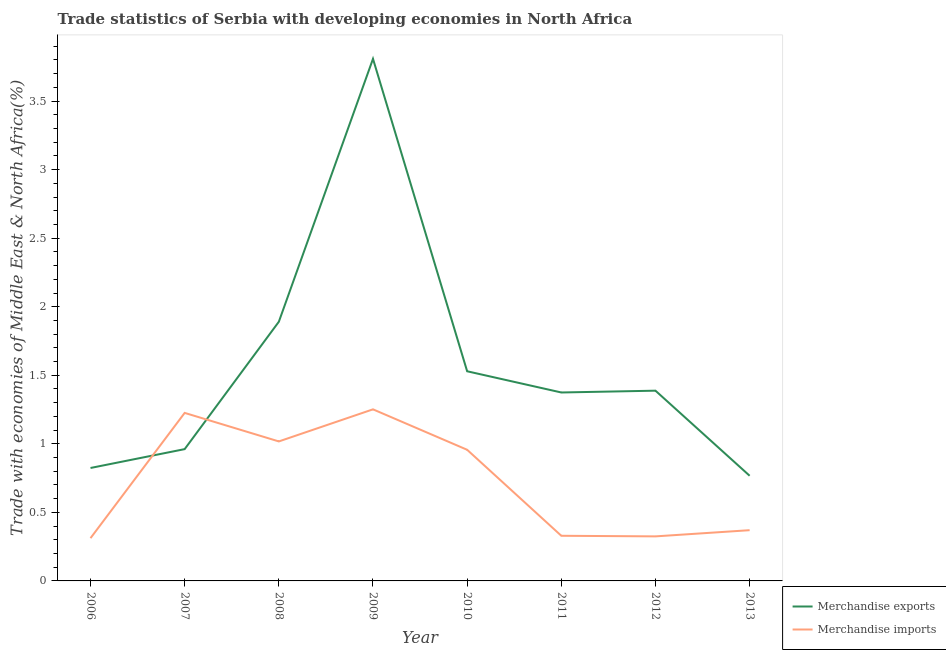How many different coloured lines are there?
Offer a very short reply. 2. Is the number of lines equal to the number of legend labels?
Your answer should be very brief. Yes. What is the merchandise exports in 2013?
Keep it short and to the point. 0.77. Across all years, what is the maximum merchandise exports?
Your answer should be very brief. 3.81. Across all years, what is the minimum merchandise imports?
Provide a succinct answer. 0.31. In which year was the merchandise exports maximum?
Your answer should be compact. 2009. In which year was the merchandise exports minimum?
Provide a short and direct response. 2013. What is the total merchandise exports in the graph?
Ensure brevity in your answer.  12.54. What is the difference between the merchandise exports in 2007 and that in 2011?
Make the answer very short. -0.41. What is the difference between the merchandise exports in 2012 and the merchandise imports in 2013?
Ensure brevity in your answer.  1.02. What is the average merchandise exports per year?
Provide a short and direct response. 1.57. In the year 2011, what is the difference between the merchandise imports and merchandise exports?
Ensure brevity in your answer.  -1.05. In how many years, is the merchandise exports greater than 1.1 %?
Offer a very short reply. 5. What is the ratio of the merchandise exports in 2007 to that in 2009?
Provide a succinct answer. 0.25. What is the difference between the highest and the second highest merchandise exports?
Offer a terse response. 1.92. What is the difference between the highest and the lowest merchandise exports?
Your response must be concise. 3.04. Is the sum of the merchandise exports in 2009 and 2010 greater than the maximum merchandise imports across all years?
Keep it short and to the point. Yes. Does the merchandise exports monotonically increase over the years?
Offer a terse response. No. How many years are there in the graph?
Provide a short and direct response. 8. What is the difference between two consecutive major ticks on the Y-axis?
Provide a succinct answer. 0.5. Does the graph contain grids?
Keep it short and to the point. No. Where does the legend appear in the graph?
Ensure brevity in your answer.  Bottom right. How are the legend labels stacked?
Your response must be concise. Vertical. What is the title of the graph?
Provide a short and direct response. Trade statistics of Serbia with developing economies in North Africa. What is the label or title of the X-axis?
Provide a short and direct response. Year. What is the label or title of the Y-axis?
Your answer should be compact. Trade with economies of Middle East & North Africa(%). What is the Trade with economies of Middle East & North Africa(%) in Merchandise exports in 2006?
Offer a very short reply. 0.82. What is the Trade with economies of Middle East & North Africa(%) of Merchandise imports in 2006?
Provide a succinct answer. 0.31. What is the Trade with economies of Middle East & North Africa(%) in Merchandise exports in 2007?
Offer a very short reply. 0.96. What is the Trade with economies of Middle East & North Africa(%) of Merchandise imports in 2007?
Your answer should be very brief. 1.23. What is the Trade with economies of Middle East & North Africa(%) in Merchandise exports in 2008?
Your answer should be very brief. 1.89. What is the Trade with economies of Middle East & North Africa(%) in Merchandise imports in 2008?
Keep it short and to the point. 1.02. What is the Trade with economies of Middle East & North Africa(%) of Merchandise exports in 2009?
Offer a terse response. 3.81. What is the Trade with economies of Middle East & North Africa(%) of Merchandise imports in 2009?
Give a very brief answer. 1.25. What is the Trade with economies of Middle East & North Africa(%) in Merchandise exports in 2010?
Your response must be concise. 1.53. What is the Trade with economies of Middle East & North Africa(%) of Merchandise imports in 2010?
Keep it short and to the point. 0.96. What is the Trade with economies of Middle East & North Africa(%) of Merchandise exports in 2011?
Your answer should be very brief. 1.37. What is the Trade with economies of Middle East & North Africa(%) of Merchandise imports in 2011?
Give a very brief answer. 0.33. What is the Trade with economies of Middle East & North Africa(%) in Merchandise exports in 2012?
Your response must be concise. 1.39. What is the Trade with economies of Middle East & North Africa(%) in Merchandise imports in 2012?
Provide a short and direct response. 0.32. What is the Trade with economies of Middle East & North Africa(%) in Merchandise exports in 2013?
Offer a very short reply. 0.77. What is the Trade with economies of Middle East & North Africa(%) of Merchandise imports in 2013?
Your response must be concise. 0.37. Across all years, what is the maximum Trade with economies of Middle East & North Africa(%) of Merchandise exports?
Your answer should be compact. 3.81. Across all years, what is the maximum Trade with economies of Middle East & North Africa(%) of Merchandise imports?
Provide a short and direct response. 1.25. Across all years, what is the minimum Trade with economies of Middle East & North Africa(%) in Merchandise exports?
Your answer should be compact. 0.77. Across all years, what is the minimum Trade with economies of Middle East & North Africa(%) in Merchandise imports?
Give a very brief answer. 0.31. What is the total Trade with economies of Middle East & North Africa(%) in Merchandise exports in the graph?
Your answer should be very brief. 12.54. What is the total Trade with economies of Middle East & North Africa(%) in Merchandise imports in the graph?
Provide a succinct answer. 5.79. What is the difference between the Trade with economies of Middle East & North Africa(%) in Merchandise exports in 2006 and that in 2007?
Offer a terse response. -0.14. What is the difference between the Trade with economies of Middle East & North Africa(%) in Merchandise imports in 2006 and that in 2007?
Keep it short and to the point. -0.91. What is the difference between the Trade with economies of Middle East & North Africa(%) of Merchandise exports in 2006 and that in 2008?
Give a very brief answer. -1.07. What is the difference between the Trade with economies of Middle East & North Africa(%) of Merchandise imports in 2006 and that in 2008?
Your answer should be compact. -0.71. What is the difference between the Trade with economies of Middle East & North Africa(%) in Merchandise exports in 2006 and that in 2009?
Your response must be concise. -2.98. What is the difference between the Trade with economies of Middle East & North Africa(%) of Merchandise imports in 2006 and that in 2009?
Offer a terse response. -0.94. What is the difference between the Trade with economies of Middle East & North Africa(%) in Merchandise exports in 2006 and that in 2010?
Make the answer very short. -0.71. What is the difference between the Trade with economies of Middle East & North Africa(%) in Merchandise imports in 2006 and that in 2010?
Offer a terse response. -0.64. What is the difference between the Trade with economies of Middle East & North Africa(%) in Merchandise exports in 2006 and that in 2011?
Your answer should be compact. -0.55. What is the difference between the Trade with economies of Middle East & North Africa(%) of Merchandise imports in 2006 and that in 2011?
Make the answer very short. -0.02. What is the difference between the Trade with economies of Middle East & North Africa(%) of Merchandise exports in 2006 and that in 2012?
Keep it short and to the point. -0.56. What is the difference between the Trade with economies of Middle East & North Africa(%) of Merchandise imports in 2006 and that in 2012?
Ensure brevity in your answer.  -0.01. What is the difference between the Trade with economies of Middle East & North Africa(%) in Merchandise exports in 2006 and that in 2013?
Give a very brief answer. 0.06. What is the difference between the Trade with economies of Middle East & North Africa(%) of Merchandise imports in 2006 and that in 2013?
Your answer should be compact. -0.06. What is the difference between the Trade with economies of Middle East & North Africa(%) in Merchandise exports in 2007 and that in 2008?
Offer a very short reply. -0.93. What is the difference between the Trade with economies of Middle East & North Africa(%) in Merchandise imports in 2007 and that in 2008?
Provide a short and direct response. 0.21. What is the difference between the Trade with economies of Middle East & North Africa(%) in Merchandise exports in 2007 and that in 2009?
Your answer should be compact. -2.85. What is the difference between the Trade with economies of Middle East & North Africa(%) of Merchandise imports in 2007 and that in 2009?
Make the answer very short. -0.03. What is the difference between the Trade with economies of Middle East & North Africa(%) of Merchandise exports in 2007 and that in 2010?
Keep it short and to the point. -0.57. What is the difference between the Trade with economies of Middle East & North Africa(%) in Merchandise imports in 2007 and that in 2010?
Your response must be concise. 0.27. What is the difference between the Trade with economies of Middle East & North Africa(%) of Merchandise exports in 2007 and that in 2011?
Make the answer very short. -0.41. What is the difference between the Trade with economies of Middle East & North Africa(%) in Merchandise imports in 2007 and that in 2011?
Keep it short and to the point. 0.9. What is the difference between the Trade with economies of Middle East & North Africa(%) of Merchandise exports in 2007 and that in 2012?
Ensure brevity in your answer.  -0.43. What is the difference between the Trade with economies of Middle East & North Africa(%) in Merchandise imports in 2007 and that in 2012?
Your answer should be very brief. 0.9. What is the difference between the Trade with economies of Middle East & North Africa(%) in Merchandise exports in 2007 and that in 2013?
Make the answer very short. 0.19. What is the difference between the Trade with economies of Middle East & North Africa(%) in Merchandise imports in 2007 and that in 2013?
Offer a terse response. 0.86. What is the difference between the Trade with economies of Middle East & North Africa(%) of Merchandise exports in 2008 and that in 2009?
Ensure brevity in your answer.  -1.92. What is the difference between the Trade with economies of Middle East & North Africa(%) of Merchandise imports in 2008 and that in 2009?
Give a very brief answer. -0.23. What is the difference between the Trade with economies of Middle East & North Africa(%) of Merchandise exports in 2008 and that in 2010?
Make the answer very short. 0.36. What is the difference between the Trade with economies of Middle East & North Africa(%) in Merchandise imports in 2008 and that in 2010?
Ensure brevity in your answer.  0.06. What is the difference between the Trade with economies of Middle East & North Africa(%) in Merchandise exports in 2008 and that in 2011?
Ensure brevity in your answer.  0.52. What is the difference between the Trade with economies of Middle East & North Africa(%) in Merchandise imports in 2008 and that in 2011?
Offer a very short reply. 0.69. What is the difference between the Trade with economies of Middle East & North Africa(%) of Merchandise exports in 2008 and that in 2012?
Your response must be concise. 0.5. What is the difference between the Trade with economies of Middle East & North Africa(%) of Merchandise imports in 2008 and that in 2012?
Offer a terse response. 0.69. What is the difference between the Trade with economies of Middle East & North Africa(%) of Merchandise exports in 2008 and that in 2013?
Ensure brevity in your answer.  1.12. What is the difference between the Trade with economies of Middle East & North Africa(%) of Merchandise imports in 2008 and that in 2013?
Provide a short and direct response. 0.65. What is the difference between the Trade with economies of Middle East & North Africa(%) of Merchandise exports in 2009 and that in 2010?
Ensure brevity in your answer.  2.28. What is the difference between the Trade with economies of Middle East & North Africa(%) in Merchandise imports in 2009 and that in 2010?
Your answer should be very brief. 0.29. What is the difference between the Trade with economies of Middle East & North Africa(%) of Merchandise exports in 2009 and that in 2011?
Make the answer very short. 2.43. What is the difference between the Trade with economies of Middle East & North Africa(%) in Merchandise imports in 2009 and that in 2011?
Your answer should be compact. 0.92. What is the difference between the Trade with economies of Middle East & North Africa(%) of Merchandise exports in 2009 and that in 2012?
Ensure brevity in your answer.  2.42. What is the difference between the Trade with economies of Middle East & North Africa(%) of Merchandise imports in 2009 and that in 2012?
Ensure brevity in your answer.  0.93. What is the difference between the Trade with economies of Middle East & North Africa(%) in Merchandise exports in 2009 and that in 2013?
Make the answer very short. 3.04. What is the difference between the Trade with economies of Middle East & North Africa(%) in Merchandise imports in 2009 and that in 2013?
Your answer should be very brief. 0.88. What is the difference between the Trade with economies of Middle East & North Africa(%) of Merchandise exports in 2010 and that in 2011?
Provide a succinct answer. 0.15. What is the difference between the Trade with economies of Middle East & North Africa(%) of Merchandise imports in 2010 and that in 2011?
Keep it short and to the point. 0.63. What is the difference between the Trade with economies of Middle East & North Africa(%) of Merchandise exports in 2010 and that in 2012?
Give a very brief answer. 0.14. What is the difference between the Trade with economies of Middle East & North Africa(%) in Merchandise imports in 2010 and that in 2012?
Provide a succinct answer. 0.63. What is the difference between the Trade with economies of Middle East & North Africa(%) of Merchandise exports in 2010 and that in 2013?
Ensure brevity in your answer.  0.76. What is the difference between the Trade with economies of Middle East & North Africa(%) of Merchandise imports in 2010 and that in 2013?
Ensure brevity in your answer.  0.59. What is the difference between the Trade with economies of Middle East & North Africa(%) in Merchandise exports in 2011 and that in 2012?
Offer a very short reply. -0.01. What is the difference between the Trade with economies of Middle East & North Africa(%) of Merchandise imports in 2011 and that in 2012?
Your response must be concise. 0. What is the difference between the Trade with economies of Middle East & North Africa(%) in Merchandise exports in 2011 and that in 2013?
Ensure brevity in your answer.  0.61. What is the difference between the Trade with economies of Middle East & North Africa(%) in Merchandise imports in 2011 and that in 2013?
Your answer should be compact. -0.04. What is the difference between the Trade with economies of Middle East & North Africa(%) of Merchandise exports in 2012 and that in 2013?
Your answer should be compact. 0.62. What is the difference between the Trade with economies of Middle East & North Africa(%) of Merchandise imports in 2012 and that in 2013?
Provide a succinct answer. -0.05. What is the difference between the Trade with economies of Middle East & North Africa(%) of Merchandise exports in 2006 and the Trade with economies of Middle East & North Africa(%) of Merchandise imports in 2007?
Ensure brevity in your answer.  -0.4. What is the difference between the Trade with economies of Middle East & North Africa(%) of Merchandise exports in 2006 and the Trade with economies of Middle East & North Africa(%) of Merchandise imports in 2008?
Your answer should be very brief. -0.19. What is the difference between the Trade with economies of Middle East & North Africa(%) in Merchandise exports in 2006 and the Trade with economies of Middle East & North Africa(%) in Merchandise imports in 2009?
Your answer should be very brief. -0.43. What is the difference between the Trade with economies of Middle East & North Africa(%) in Merchandise exports in 2006 and the Trade with economies of Middle East & North Africa(%) in Merchandise imports in 2010?
Offer a very short reply. -0.13. What is the difference between the Trade with economies of Middle East & North Africa(%) in Merchandise exports in 2006 and the Trade with economies of Middle East & North Africa(%) in Merchandise imports in 2011?
Your response must be concise. 0.49. What is the difference between the Trade with economies of Middle East & North Africa(%) in Merchandise exports in 2006 and the Trade with economies of Middle East & North Africa(%) in Merchandise imports in 2012?
Keep it short and to the point. 0.5. What is the difference between the Trade with economies of Middle East & North Africa(%) in Merchandise exports in 2006 and the Trade with economies of Middle East & North Africa(%) in Merchandise imports in 2013?
Make the answer very short. 0.45. What is the difference between the Trade with economies of Middle East & North Africa(%) of Merchandise exports in 2007 and the Trade with economies of Middle East & North Africa(%) of Merchandise imports in 2008?
Give a very brief answer. -0.06. What is the difference between the Trade with economies of Middle East & North Africa(%) in Merchandise exports in 2007 and the Trade with economies of Middle East & North Africa(%) in Merchandise imports in 2009?
Offer a terse response. -0.29. What is the difference between the Trade with economies of Middle East & North Africa(%) in Merchandise exports in 2007 and the Trade with economies of Middle East & North Africa(%) in Merchandise imports in 2010?
Offer a terse response. 0. What is the difference between the Trade with economies of Middle East & North Africa(%) of Merchandise exports in 2007 and the Trade with economies of Middle East & North Africa(%) of Merchandise imports in 2011?
Your answer should be very brief. 0.63. What is the difference between the Trade with economies of Middle East & North Africa(%) of Merchandise exports in 2007 and the Trade with economies of Middle East & North Africa(%) of Merchandise imports in 2012?
Offer a terse response. 0.64. What is the difference between the Trade with economies of Middle East & North Africa(%) of Merchandise exports in 2007 and the Trade with economies of Middle East & North Africa(%) of Merchandise imports in 2013?
Your answer should be compact. 0.59. What is the difference between the Trade with economies of Middle East & North Africa(%) of Merchandise exports in 2008 and the Trade with economies of Middle East & North Africa(%) of Merchandise imports in 2009?
Offer a very short reply. 0.64. What is the difference between the Trade with economies of Middle East & North Africa(%) in Merchandise exports in 2008 and the Trade with economies of Middle East & North Africa(%) in Merchandise imports in 2010?
Your answer should be very brief. 0.93. What is the difference between the Trade with economies of Middle East & North Africa(%) in Merchandise exports in 2008 and the Trade with economies of Middle East & North Africa(%) in Merchandise imports in 2011?
Provide a short and direct response. 1.56. What is the difference between the Trade with economies of Middle East & North Africa(%) of Merchandise exports in 2008 and the Trade with economies of Middle East & North Africa(%) of Merchandise imports in 2012?
Provide a short and direct response. 1.57. What is the difference between the Trade with economies of Middle East & North Africa(%) in Merchandise exports in 2008 and the Trade with economies of Middle East & North Africa(%) in Merchandise imports in 2013?
Give a very brief answer. 1.52. What is the difference between the Trade with economies of Middle East & North Africa(%) in Merchandise exports in 2009 and the Trade with economies of Middle East & North Africa(%) in Merchandise imports in 2010?
Offer a very short reply. 2.85. What is the difference between the Trade with economies of Middle East & North Africa(%) in Merchandise exports in 2009 and the Trade with economies of Middle East & North Africa(%) in Merchandise imports in 2011?
Keep it short and to the point. 3.48. What is the difference between the Trade with economies of Middle East & North Africa(%) in Merchandise exports in 2009 and the Trade with economies of Middle East & North Africa(%) in Merchandise imports in 2012?
Make the answer very short. 3.48. What is the difference between the Trade with economies of Middle East & North Africa(%) in Merchandise exports in 2009 and the Trade with economies of Middle East & North Africa(%) in Merchandise imports in 2013?
Give a very brief answer. 3.44. What is the difference between the Trade with economies of Middle East & North Africa(%) of Merchandise exports in 2010 and the Trade with economies of Middle East & North Africa(%) of Merchandise imports in 2011?
Make the answer very short. 1.2. What is the difference between the Trade with economies of Middle East & North Africa(%) in Merchandise exports in 2010 and the Trade with economies of Middle East & North Africa(%) in Merchandise imports in 2012?
Give a very brief answer. 1.2. What is the difference between the Trade with economies of Middle East & North Africa(%) in Merchandise exports in 2010 and the Trade with economies of Middle East & North Africa(%) in Merchandise imports in 2013?
Provide a short and direct response. 1.16. What is the difference between the Trade with economies of Middle East & North Africa(%) of Merchandise exports in 2011 and the Trade with economies of Middle East & North Africa(%) of Merchandise imports in 2012?
Keep it short and to the point. 1.05. What is the difference between the Trade with economies of Middle East & North Africa(%) of Merchandise exports in 2012 and the Trade with economies of Middle East & North Africa(%) of Merchandise imports in 2013?
Keep it short and to the point. 1.02. What is the average Trade with economies of Middle East & North Africa(%) of Merchandise exports per year?
Ensure brevity in your answer.  1.57. What is the average Trade with economies of Middle East & North Africa(%) of Merchandise imports per year?
Provide a short and direct response. 0.72. In the year 2006, what is the difference between the Trade with economies of Middle East & North Africa(%) of Merchandise exports and Trade with economies of Middle East & North Africa(%) of Merchandise imports?
Your answer should be very brief. 0.51. In the year 2007, what is the difference between the Trade with economies of Middle East & North Africa(%) of Merchandise exports and Trade with economies of Middle East & North Africa(%) of Merchandise imports?
Provide a succinct answer. -0.26. In the year 2008, what is the difference between the Trade with economies of Middle East & North Africa(%) of Merchandise exports and Trade with economies of Middle East & North Africa(%) of Merchandise imports?
Give a very brief answer. 0.87. In the year 2009, what is the difference between the Trade with economies of Middle East & North Africa(%) of Merchandise exports and Trade with economies of Middle East & North Africa(%) of Merchandise imports?
Your answer should be very brief. 2.56. In the year 2010, what is the difference between the Trade with economies of Middle East & North Africa(%) of Merchandise exports and Trade with economies of Middle East & North Africa(%) of Merchandise imports?
Offer a very short reply. 0.57. In the year 2011, what is the difference between the Trade with economies of Middle East & North Africa(%) of Merchandise exports and Trade with economies of Middle East & North Africa(%) of Merchandise imports?
Keep it short and to the point. 1.05. In the year 2012, what is the difference between the Trade with economies of Middle East & North Africa(%) in Merchandise exports and Trade with economies of Middle East & North Africa(%) in Merchandise imports?
Offer a very short reply. 1.06. In the year 2013, what is the difference between the Trade with economies of Middle East & North Africa(%) in Merchandise exports and Trade with economies of Middle East & North Africa(%) in Merchandise imports?
Give a very brief answer. 0.4. What is the ratio of the Trade with economies of Middle East & North Africa(%) in Merchandise exports in 2006 to that in 2007?
Ensure brevity in your answer.  0.86. What is the ratio of the Trade with economies of Middle East & North Africa(%) of Merchandise imports in 2006 to that in 2007?
Ensure brevity in your answer.  0.25. What is the ratio of the Trade with economies of Middle East & North Africa(%) in Merchandise exports in 2006 to that in 2008?
Your answer should be very brief. 0.44. What is the ratio of the Trade with economies of Middle East & North Africa(%) of Merchandise imports in 2006 to that in 2008?
Provide a succinct answer. 0.31. What is the ratio of the Trade with economies of Middle East & North Africa(%) in Merchandise exports in 2006 to that in 2009?
Make the answer very short. 0.22. What is the ratio of the Trade with economies of Middle East & North Africa(%) of Merchandise imports in 2006 to that in 2009?
Provide a short and direct response. 0.25. What is the ratio of the Trade with economies of Middle East & North Africa(%) in Merchandise exports in 2006 to that in 2010?
Make the answer very short. 0.54. What is the ratio of the Trade with economies of Middle East & North Africa(%) in Merchandise imports in 2006 to that in 2010?
Ensure brevity in your answer.  0.33. What is the ratio of the Trade with economies of Middle East & North Africa(%) of Merchandise exports in 2006 to that in 2011?
Provide a short and direct response. 0.6. What is the ratio of the Trade with economies of Middle East & North Africa(%) of Merchandise imports in 2006 to that in 2011?
Offer a terse response. 0.95. What is the ratio of the Trade with economies of Middle East & North Africa(%) in Merchandise exports in 2006 to that in 2012?
Make the answer very short. 0.59. What is the ratio of the Trade with economies of Middle East & North Africa(%) of Merchandise imports in 2006 to that in 2012?
Your response must be concise. 0.96. What is the ratio of the Trade with economies of Middle East & North Africa(%) of Merchandise exports in 2006 to that in 2013?
Make the answer very short. 1.07. What is the ratio of the Trade with economies of Middle East & North Africa(%) in Merchandise imports in 2006 to that in 2013?
Provide a succinct answer. 0.84. What is the ratio of the Trade with economies of Middle East & North Africa(%) in Merchandise exports in 2007 to that in 2008?
Ensure brevity in your answer.  0.51. What is the ratio of the Trade with economies of Middle East & North Africa(%) of Merchandise imports in 2007 to that in 2008?
Provide a short and direct response. 1.2. What is the ratio of the Trade with economies of Middle East & North Africa(%) in Merchandise exports in 2007 to that in 2009?
Your response must be concise. 0.25. What is the ratio of the Trade with economies of Middle East & North Africa(%) of Merchandise imports in 2007 to that in 2009?
Ensure brevity in your answer.  0.98. What is the ratio of the Trade with economies of Middle East & North Africa(%) of Merchandise exports in 2007 to that in 2010?
Ensure brevity in your answer.  0.63. What is the ratio of the Trade with economies of Middle East & North Africa(%) of Merchandise imports in 2007 to that in 2010?
Your answer should be compact. 1.28. What is the ratio of the Trade with economies of Middle East & North Africa(%) in Merchandise exports in 2007 to that in 2011?
Your response must be concise. 0.7. What is the ratio of the Trade with economies of Middle East & North Africa(%) in Merchandise imports in 2007 to that in 2011?
Give a very brief answer. 3.72. What is the ratio of the Trade with economies of Middle East & North Africa(%) of Merchandise exports in 2007 to that in 2012?
Provide a short and direct response. 0.69. What is the ratio of the Trade with economies of Middle East & North Africa(%) in Merchandise imports in 2007 to that in 2012?
Your answer should be very brief. 3.77. What is the ratio of the Trade with economies of Middle East & North Africa(%) in Merchandise exports in 2007 to that in 2013?
Your response must be concise. 1.25. What is the ratio of the Trade with economies of Middle East & North Africa(%) in Merchandise imports in 2007 to that in 2013?
Keep it short and to the point. 3.31. What is the ratio of the Trade with economies of Middle East & North Africa(%) in Merchandise exports in 2008 to that in 2009?
Ensure brevity in your answer.  0.5. What is the ratio of the Trade with economies of Middle East & North Africa(%) of Merchandise imports in 2008 to that in 2009?
Ensure brevity in your answer.  0.81. What is the ratio of the Trade with economies of Middle East & North Africa(%) of Merchandise exports in 2008 to that in 2010?
Your response must be concise. 1.24. What is the ratio of the Trade with economies of Middle East & North Africa(%) of Merchandise imports in 2008 to that in 2010?
Your answer should be very brief. 1.06. What is the ratio of the Trade with economies of Middle East & North Africa(%) of Merchandise exports in 2008 to that in 2011?
Make the answer very short. 1.38. What is the ratio of the Trade with economies of Middle East & North Africa(%) of Merchandise imports in 2008 to that in 2011?
Offer a terse response. 3.09. What is the ratio of the Trade with economies of Middle East & North Africa(%) in Merchandise exports in 2008 to that in 2012?
Offer a terse response. 1.36. What is the ratio of the Trade with economies of Middle East & North Africa(%) in Merchandise imports in 2008 to that in 2012?
Provide a short and direct response. 3.13. What is the ratio of the Trade with economies of Middle East & North Africa(%) in Merchandise exports in 2008 to that in 2013?
Make the answer very short. 2.46. What is the ratio of the Trade with economies of Middle East & North Africa(%) in Merchandise imports in 2008 to that in 2013?
Provide a succinct answer. 2.75. What is the ratio of the Trade with economies of Middle East & North Africa(%) in Merchandise exports in 2009 to that in 2010?
Offer a terse response. 2.49. What is the ratio of the Trade with economies of Middle East & North Africa(%) of Merchandise imports in 2009 to that in 2010?
Give a very brief answer. 1.31. What is the ratio of the Trade with economies of Middle East & North Africa(%) in Merchandise exports in 2009 to that in 2011?
Offer a very short reply. 2.77. What is the ratio of the Trade with economies of Middle East & North Africa(%) in Merchandise imports in 2009 to that in 2011?
Your answer should be very brief. 3.8. What is the ratio of the Trade with economies of Middle East & North Africa(%) of Merchandise exports in 2009 to that in 2012?
Provide a short and direct response. 2.74. What is the ratio of the Trade with economies of Middle East & North Africa(%) of Merchandise imports in 2009 to that in 2012?
Provide a short and direct response. 3.85. What is the ratio of the Trade with economies of Middle East & North Africa(%) in Merchandise exports in 2009 to that in 2013?
Your answer should be compact. 4.96. What is the ratio of the Trade with economies of Middle East & North Africa(%) in Merchandise imports in 2009 to that in 2013?
Keep it short and to the point. 3.38. What is the ratio of the Trade with economies of Middle East & North Africa(%) in Merchandise exports in 2010 to that in 2011?
Your response must be concise. 1.11. What is the ratio of the Trade with economies of Middle East & North Africa(%) in Merchandise imports in 2010 to that in 2011?
Keep it short and to the point. 2.91. What is the ratio of the Trade with economies of Middle East & North Africa(%) of Merchandise exports in 2010 to that in 2012?
Your response must be concise. 1.1. What is the ratio of the Trade with economies of Middle East & North Africa(%) in Merchandise imports in 2010 to that in 2012?
Your answer should be compact. 2.94. What is the ratio of the Trade with economies of Middle East & North Africa(%) in Merchandise exports in 2010 to that in 2013?
Your answer should be compact. 1.99. What is the ratio of the Trade with economies of Middle East & North Africa(%) of Merchandise imports in 2010 to that in 2013?
Give a very brief answer. 2.59. What is the ratio of the Trade with economies of Middle East & North Africa(%) in Merchandise exports in 2011 to that in 2012?
Make the answer very short. 0.99. What is the ratio of the Trade with economies of Middle East & North Africa(%) of Merchandise imports in 2011 to that in 2012?
Your answer should be very brief. 1.01. What is the ratio of the Trade with economies of Middle East & North Africa(%) in Merchandise exports in 2011 to that in 2013?
Keep it short and to the point. 1.79. What is the ratio of the Trade with economies of Middle East & North Africa(%) of Merchandise imports in 2011 to that in 2013?
Your answer should be very brief. 0.89. What is the ratio of the Trade with economies of Middle East & North Africa(%) in Merchandise exports in 2012 to that in 2013?
Offer a terse response. 1.81. What is the ratio of the Trade with economies of Middle East & North Africa(%) in Merchandise imports in 2012 to that in 2013?
Offer a terse response. 0.88. What is the difference between the highest and the second highest Trade with economies of Middle East & North Africa(%) in Merchandise exports?
Provide a short and direct response. 1.92. What is the difference between the highest and the second highest Trade with economies of Middle East & North Africa(%) in Merchandise imports?
Your answer should be compact. 0.03. What is the difference between the highest and the lowest Trade with economies of Middle East & North Africa(%) of Merchandise exports?
Make the answer very short. 3.04. What is the difference between the highest and the lowest Trade with economies of Middle East & North Africa(%) of Merchandise imports?
Make the answer very short. 0.94. 